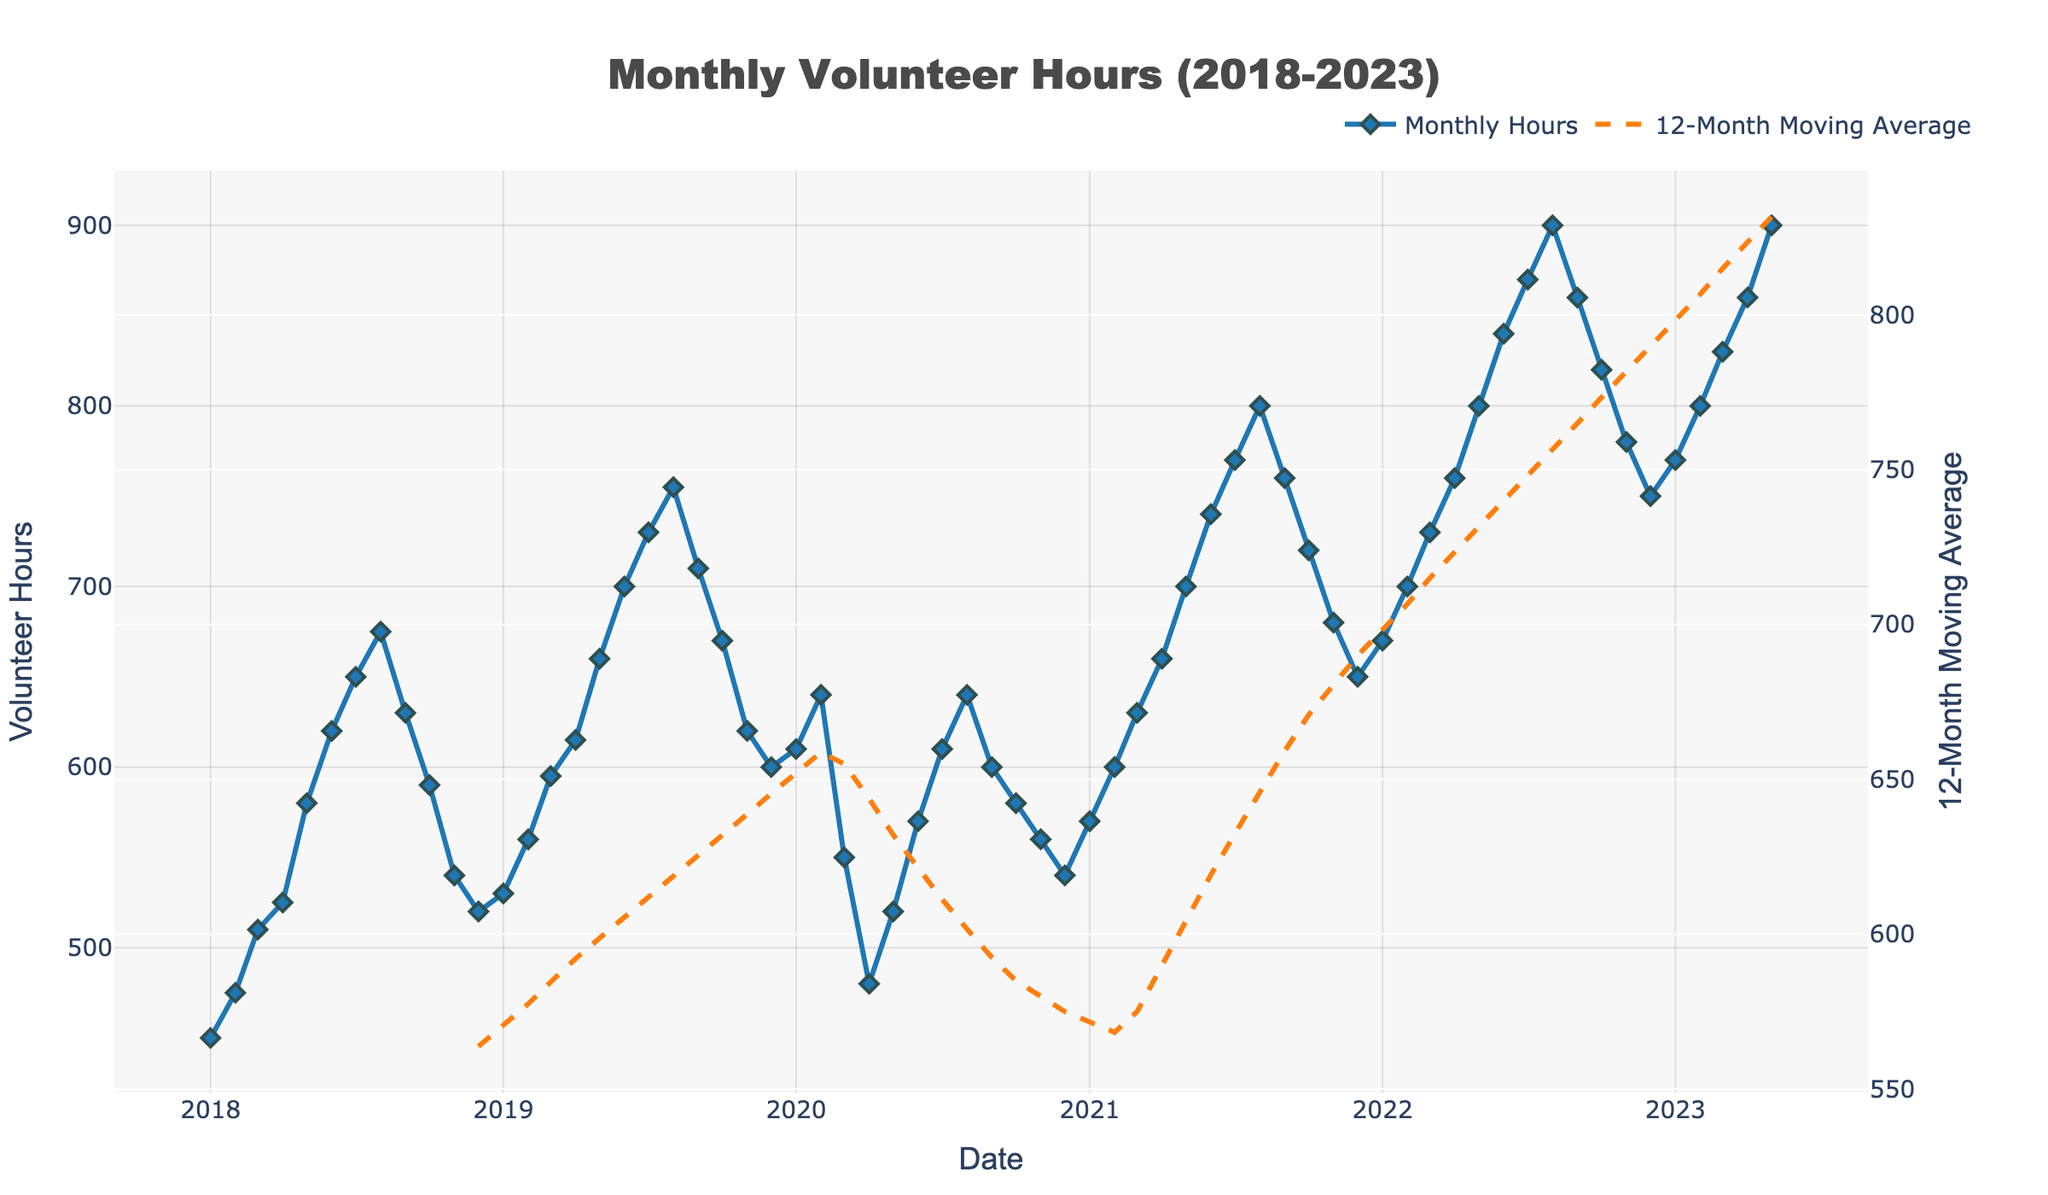What's the highest number of volunteer hours recorded in a month? To find this, look for the highest peak in the line chart. The highest point visually stands out as the tallest marker. The peak occurs in May 2023, which shows 900 hours.
Answer: 900 What was the trend in volunteer hours from Mar 2020 to Jun 2020? Identify the specific months Mar 2020 to Jun 2020 and observe the trend line. The hours decreased sharply from 550 in Mar 2020 to 480 in Apr 2020 and then gradually increased to 570 in Jun 2020.
Answer: Decrease then Increase What is the difference in volunteer hours between the lowest and highest months in 2020? Identify the lowest and highest points for 2020. The lowest is in Apr 2020 with 480 hours, and the highest is in Feb 2020 with 640 hours. Compute the difference: 640 - 480 = 160.
Answer: 160 Between which two consecutive months in 2021 did the volunteer hours increase the most? Scan 2021 for the most significant increase between two consecutive months. Between Jun 2021 (740 hours) and Jul 2021 (770 hours), there's the largest increase of 30 hours.
Answer: June and July When did the 12-month moving average first exceed 700 hours? Examine the dashed line for the moving average and check when it first goes over the 700-hour mark. In Feb 2022, it first crosses 700 hours.
Answer: Feb 2022 How did volunteer hours trend from the start of 2023 to May 2023? Inspect the line chart from Jan 2023 to May 2023. The trend shows a steady increase from 770 hours in Jan 2023 to 900 hours in May 2023.
Answer: Increasing Compare the volunteer hours of Oct 2018 and Oct 2019. Which month had more hours, and by how much? Locate the points for Oct 2018 (590 hours) and Oct 2019 (670 hours). Oct 2019 had more hours by 670 - 590 = 80 hours.
Answer: Oct 2019 by 80 What was the average number of volunteer hours in the year 2021? Calculate the average by summing the monthly hours for 2021 and dividing by 12. Total for 2021: 570 + 600 + 630 + 660 + 700 + 740 + 770 + 800 + 760 + 720 + 680 + 650 = 8,980. The average is 8,980 / 12 = 748.33.
Answer: 748.33 What's the percentage increase in volunteer hours from Jan 2020 to Jan 2023? Calculate the percentage increase, where Jan 2020 had 610 hours and Jan 2023 had 770 hours. Percentage increase = ((770 - 610) / 610) * 100 = 26.23%.
Answer: 26.23 During which year did the volunteer hours fluctuate the most? Look for the year with the largest difference between high and low points. 2022 shows the highest fluctuation from 670 in Jan to 900 in Aug, a range of 230 hours.
Answer: 2022 